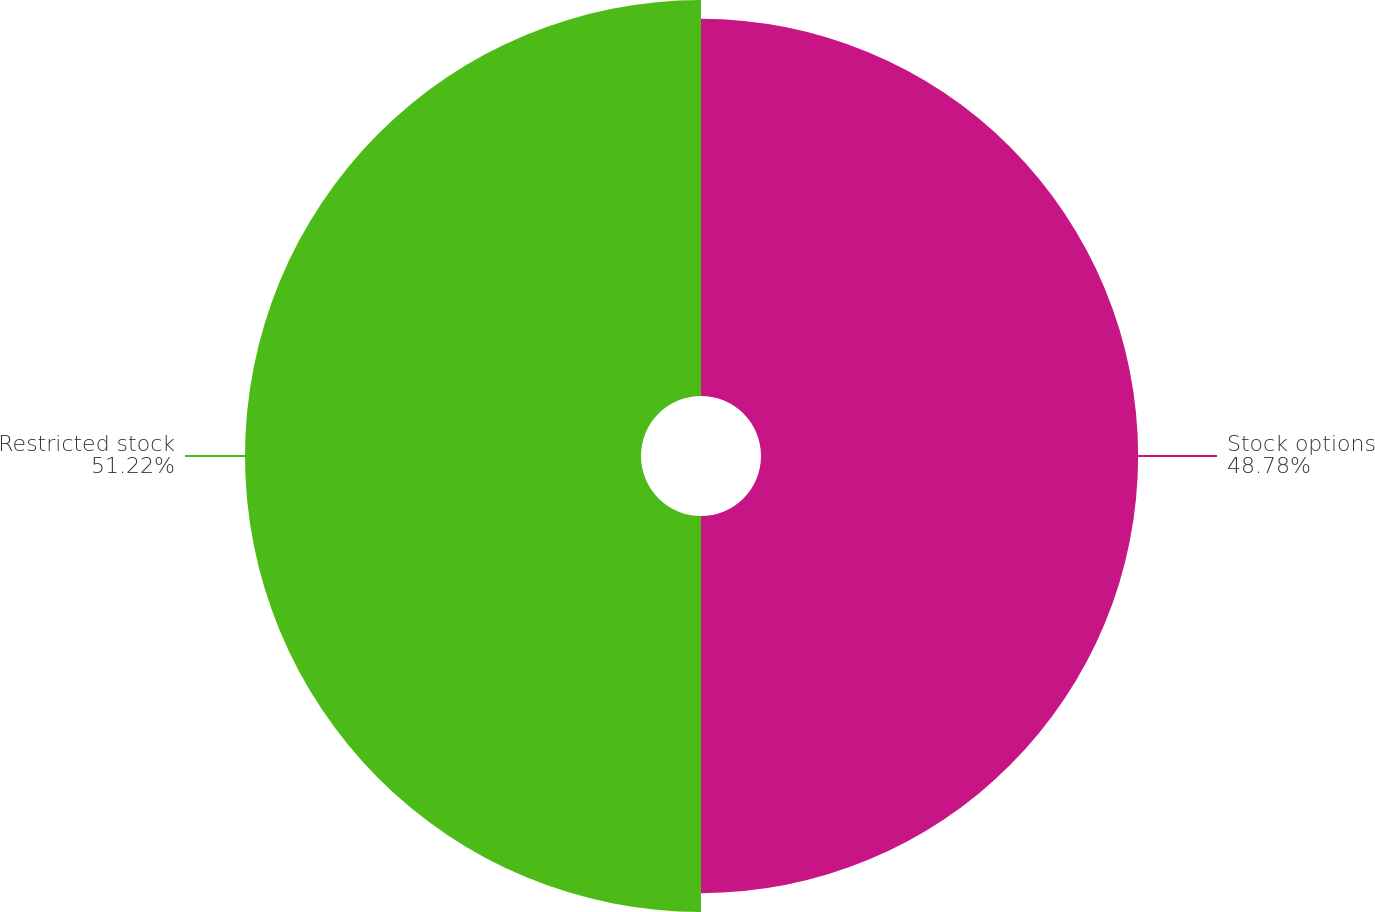Convert chart to OTSL. <chart><loc_0><loc_0><loc_500><loc_500><pie_chart><fcel>Stock options<fcel>Restricted stock<nl><fcel>48.78%<fcel>51.22%<nl></chart> 